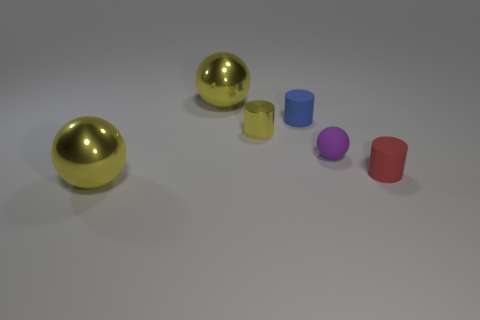Subtract all yellow cylinders. How many cylinders are left? 2 Add 2 red matte objects. How many objects exist? 8 Subtract all red cylinders. How many yellow balls are left? 2 Subtract all blue cylinders. How many cylinders are left? 2 Subtract 2 cylinders. How many cylinders are left? 1 Add 5 small red matte things. How many small red matte things exist? 6 Subtract 0 cyan spheres. How many objects are left? 6 Subtract all brown spheres. Subtract all green cylinders. How many spheres are left? 3 Subtract all small yellow metal objects. Subtract all tiny red objects. How many objects are left? 4 Add 2 small red rubber cylinders. How many small red rubber cylinders are left? 3 